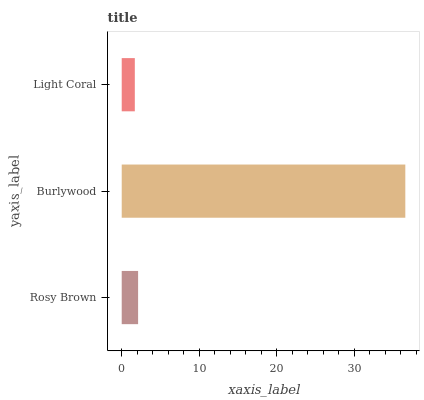Is Light Coral the minimum?
Answer yes or no. Yes. Is Burlywood the maximum?
Answer yes or no. Yes. Is Burlywood the minimum?
Answer yes or no. No. Is Light Coral the maximum?
Answer yes or no. No. Is Burlywood greater than Light Coral?
Answer yes or no. Yes. Is Light Coral less than Burlywood?
Answer yes or no. Yes. Is Light Coral greater than Burlywood?
Answer yes or no. No. Is Burlywood less than Light Coral?
Answer yes or no. No. Is Rosy Brown the high median?
Answer yes or no. Yes. Is Rosy Brown the low median?
Answer yes or no. Yes. Is Burlywood the high median?
Answer yes or no. No. Is Light Coral the low median?
Answer yes or no. No. 